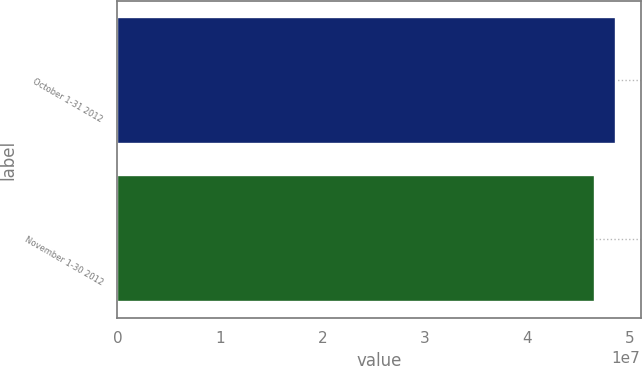Convert chart to OTSL. <chart><loc_0><loc_0><loc_500><loc_500><bar_chart><fcel>October 1-31 2012<fcel>November 1-30 2012<nl><fcel>4.86168e+07<fcel>4.65876e+07<nl></chart> 